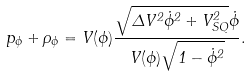Convert formula to latex. <formula><loc_0><loc_0><loc_500><loc_500>p _ { \phi } + \rho _ { \phi } = V ( \phi ) \frac { \sqrt { \Delta V ^ { 2 } \dot { \phi } ^ { 2 } + V _ { S Q } ^ { 2 } } \dot { \phi } } { V ( \phi ) \sqrt { 1 - \dot { \phi } ^ { 2 } } } .</formula> 